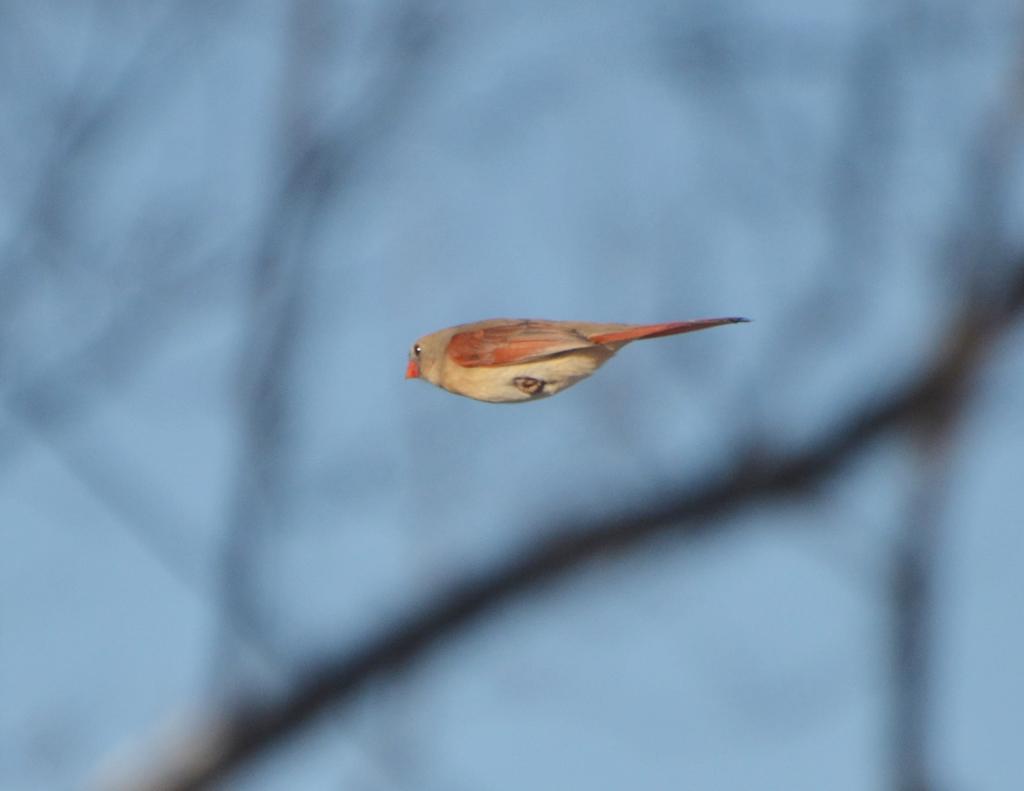Describe this image in one or two sentences. In this picture we can see a small bird in the blue sky. 